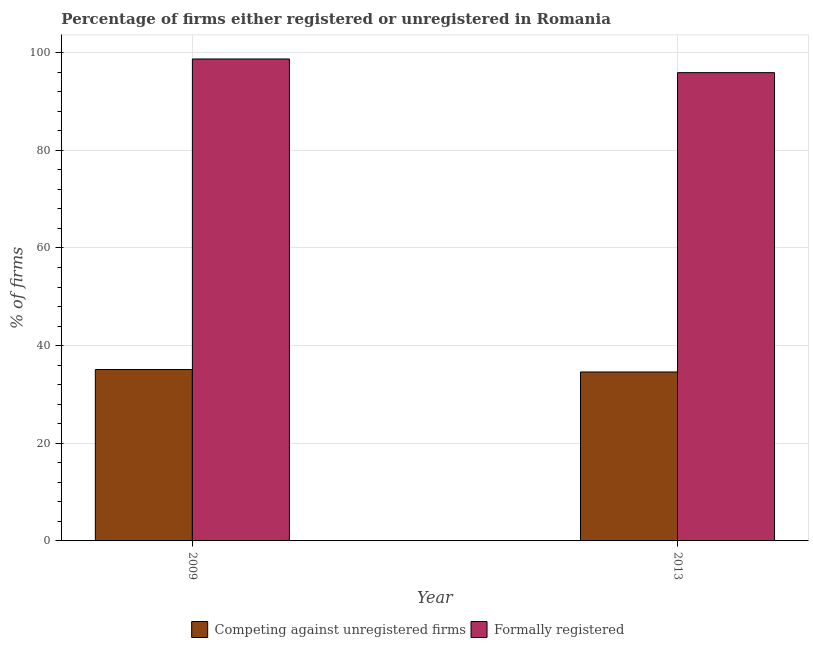How many different coloured bars are there?
Your response must be concise. 2. How many bars are there on the 1st tick from the left?
Ensure brevity in your answer.  2. How many bars are there on the 2nd tick from the right?
Your answer should be compact. 2. What is the percentage of formally registered firms in 2013?
Give a very brief answer. 95.9. Across all years, what is the maximum percentage of formally registered firms?
Keep it short and to the point. 98.7. Across all years, what is the minimum percentage of formally registered firms?
Give a very brief answer. 95.9. In which year was the percentage of registered firms minimum?
Provide a short and direct response. 2013. What is the total percentage of formally registered firms in the graph?
Provide a short and direct response. 194.6. What is the difference between the percentage of formally registered firms in 2009 and that in 2013?
Give a very brief answer. 2.8. What is the difference between the percentage of registered firms in 2009 and the percentage of formally registered firms in 2013?
Your response must be concise. 0.5. What is the average percentage of formally registered firms per year?
Your answer should be very brief. 97.3. In the year 2009, what is the difference between the percentage of registered firms and percentage of formally registered firms?
Offer a very short reply. 0. What is the ratio of the percentage of formally registered firms in 2009 to that in 2013?
Your answer should be compact. 1.03. What does the 2nd bar from the left in 2009 represents?
Your response must be concise. Formally registered. What does the 2nd bar from the right in 2013 represents?
Give a very brief answer. Competing against unregistered firms. How many years are there in the graph?
Your response must be concise. 2. What is the difference between two consecutive major ticks on the Y-axis?
Offer a terse response. 20. Does the graph contain any zero values?
Your answer should be very brief. No. How are the legend labels stacked?
Offer a terse response. Horizontal. What is the title of the graph?
Give a very brief answer. Percentage of firms either registered or unregistered in Romania. Does "Measles" appear as one of the legend labels in the graph?
Your answer should be compact. No. What is the label or title of the X-axis?
Offer a terse response. Year. What is the label or title of the Y-axis?
Provide a succinct answer. % of firms. What is the % of firms of Competing against unregistered firms in 2009?
Your answer should be compact. 35.1. What is the % of firms in Formally registered in 2009?
Keep it short and to the point. 98.7. What is the % of firms in Competing against unregistered firms in 2013?
Provide a short and direct response. 34.6. What is the % of firms of Formally registered in 2013?
Provide a succinct answer. 95.9. Across all years, what is the maximum % of firms of Competing against unregistered firms?
Keep it short and to the point. 35.1. Across all years, what is the maximum % of firms in Formally registered?
Give a very brief answer. 98.7. Across all years, what is the minimum % of firms in Competing against unregistered firms?
Provide a succinct answer. 34.6. Across all years, what is the minimum % of firms of Formally registered?
Keep it short and to the point. 95.9. What is the total % of firms of Competing against unregistered firms in the graph?
Give a very brief answer. 69.7. What is the total % of firms of Formally registered in the graph?
Your answer should be compact. 194.6. What is the difference between the % of firms of Competing against unregistered firms in 2009 and that in 2013?
Provide a succinct answer. 0.5. What is the difference between the % of firms in Competing against unregistered firms in 2009 and the % of firms in Formally registered in 2013?
Your answer should be compact. -60.8. What is the average % of firms in Competing against unregistered firms per year?
Keep it short and to the point. 34.85. What is the average % of firms in Formally registered per year?
Your answer should be very brief. 97.3. In the year 2009, what is the difference between the % of firms in Competing against unregistered firms and % of firms in Formally registered?
Ensure brevity in your answer.  -63.6. In the year 2013, what is the difference between the % of firms in Competing against unregistered firms and % of firms in Formally registered?
Your answer should be very brief. -61.3. What is the ratio of the % of firms in Competing against unregistered firms in 2009 to that in 2013?
Provide a succinct answer. 1.01. What is the ratio of the % of firms of Formally registered in 2009 to that in 2013?
Your answer should be very brief. 1.03. What is the difference between the highest and the second highest % of firms of Competing against unregistered firms?
Make the answer very short. 0.5. What is the difference between the highest and the second highest % of firms of Formally registered?
Provide a short and direct response. 2.8. What is the difference between the highest and the lowest % of firms in Formally registered?
Your response must be concise. 2.8. 